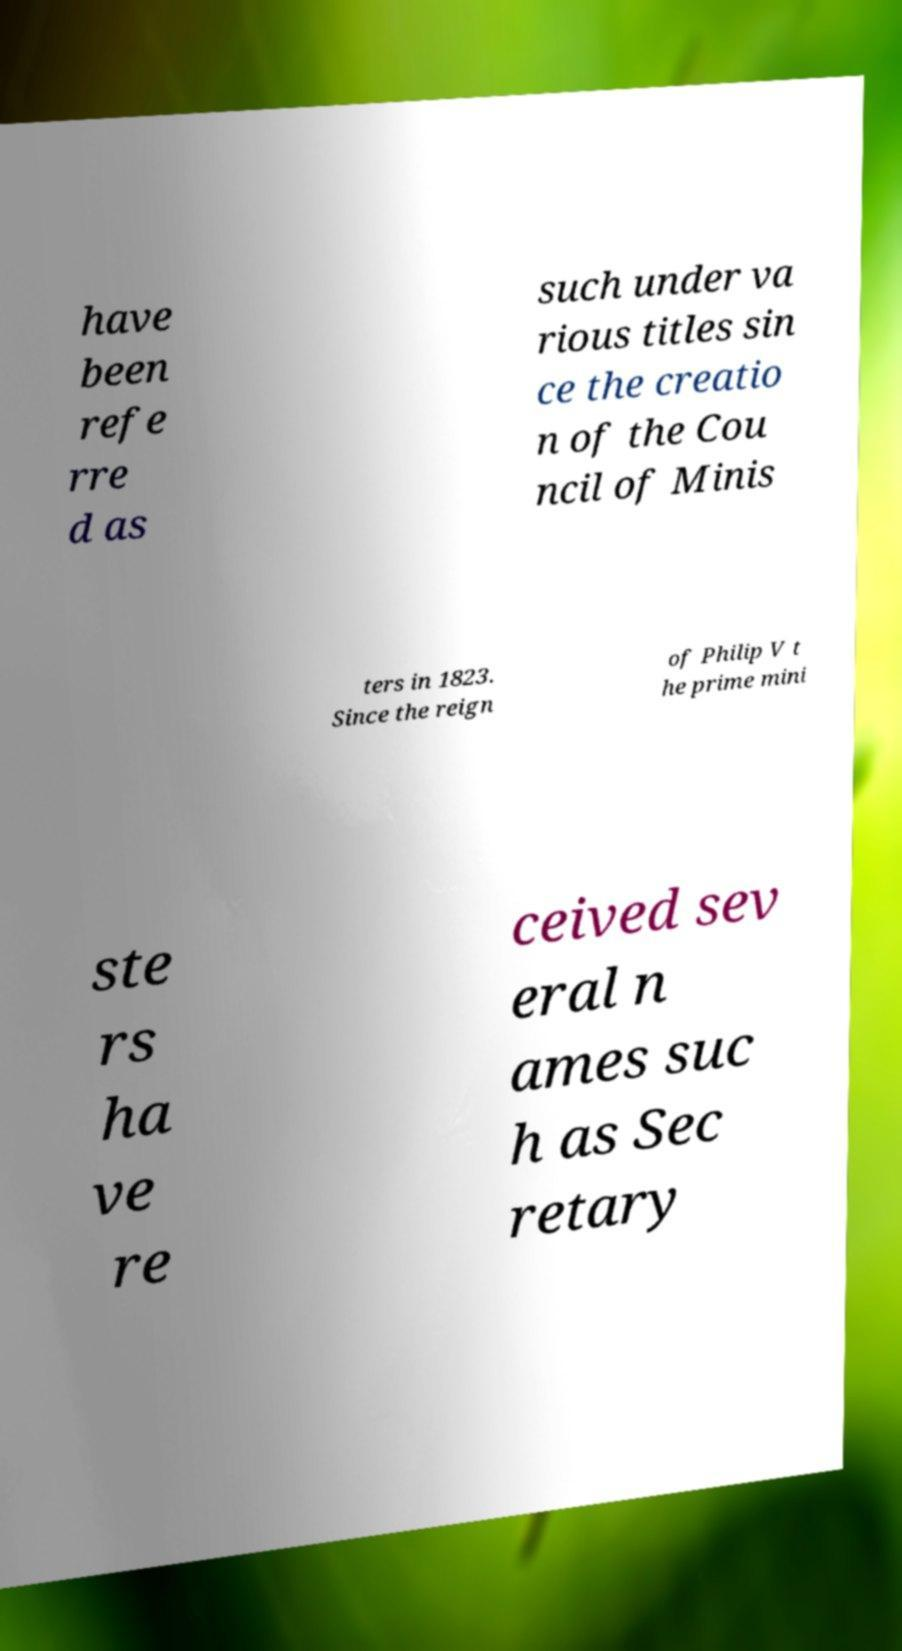Can you read and provide the text displayed in the image?This photo seems to have some interesting text. Can you extract and type it out for me? have been refe rre d as such under va rious titles sin ce the creatio n of the Cou ncil of Minis ters in 1823. Since the reign of Philip V t he prime mini ste rs ha ve re ceived sev eral n ames suc h as Sec retary 